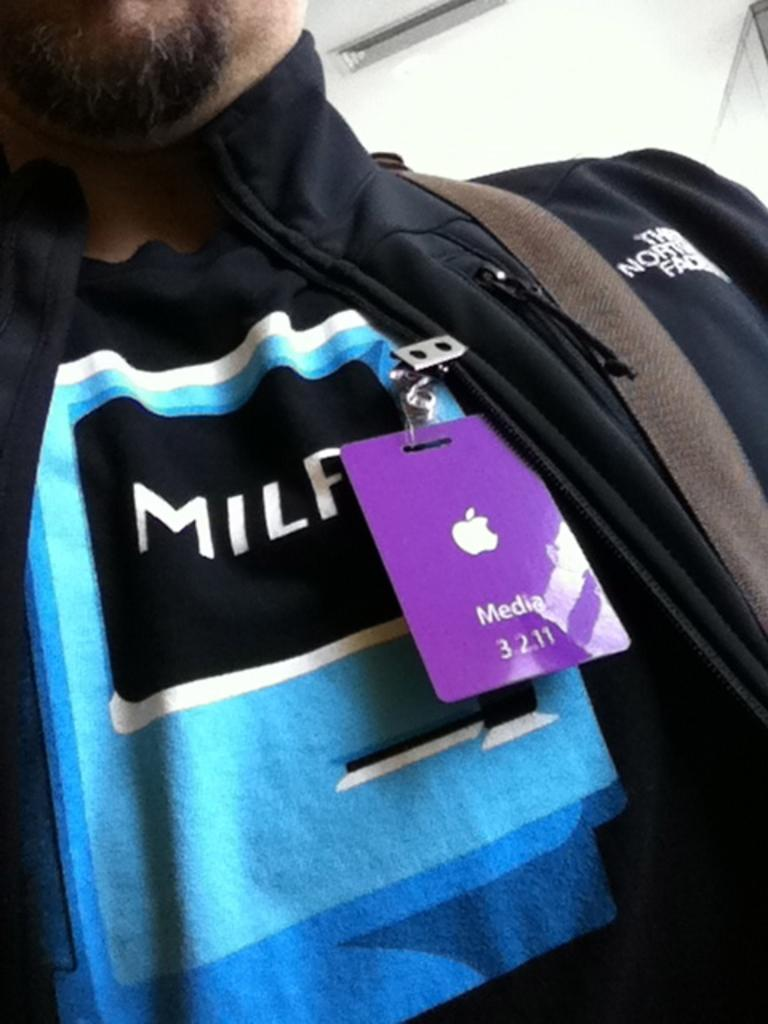Who or what is the main subject of the image? There is a person in the image. What can be seen attached to the person's jacket? The person has a card attached to their jacket. What color is the background of the image? The background of the image is white. What type of brush is being used by the person in the image? There is no brush present in the image. 